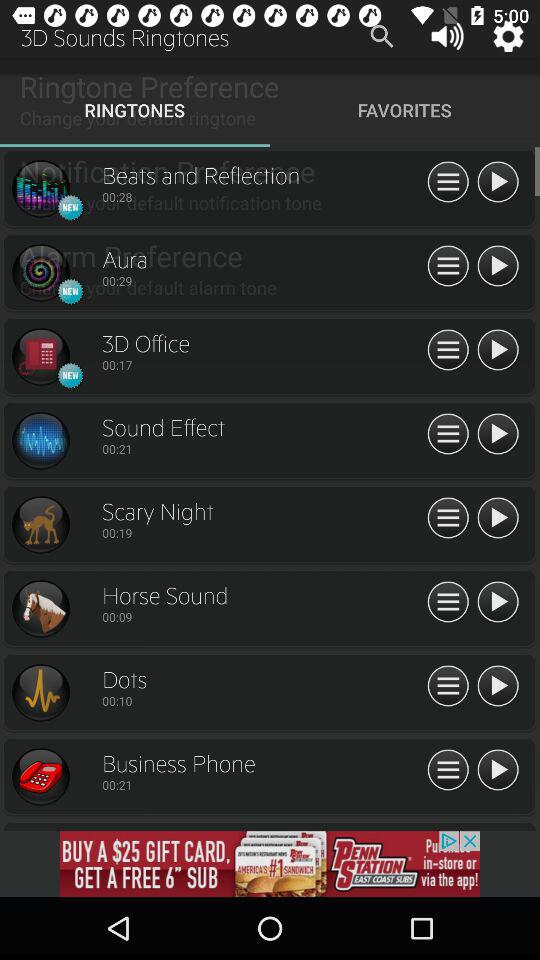Which tab is selected? The selected tab is Ringtones. 